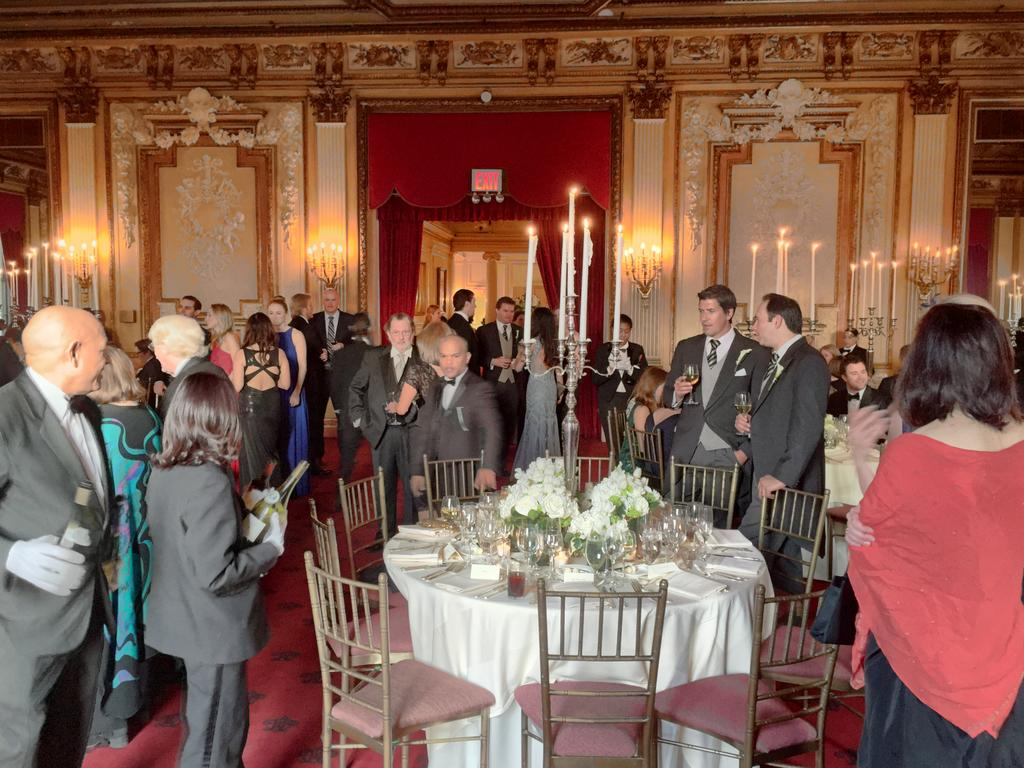How many people are in the image? There is a group of people standing in the image. Where are the people standing? The people are standing on the floor. What furniture is present in the image? There is a table and chairs beside the table in the image. What is on top of the table? There are objects on the table in the image. What type of blood is visible on the floor in the image? There is no blood visible on the floor in the image. 